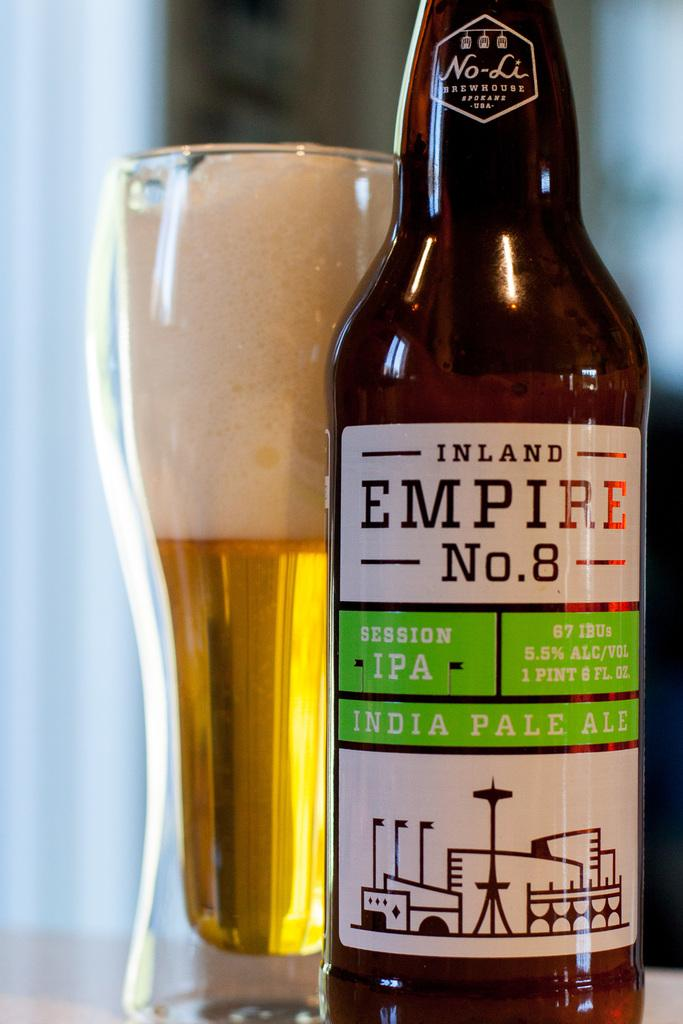<image>
Render a clear and concise summary of the photo. A bottle of beer Called Inland Empire No. 8 is in front of glass. 